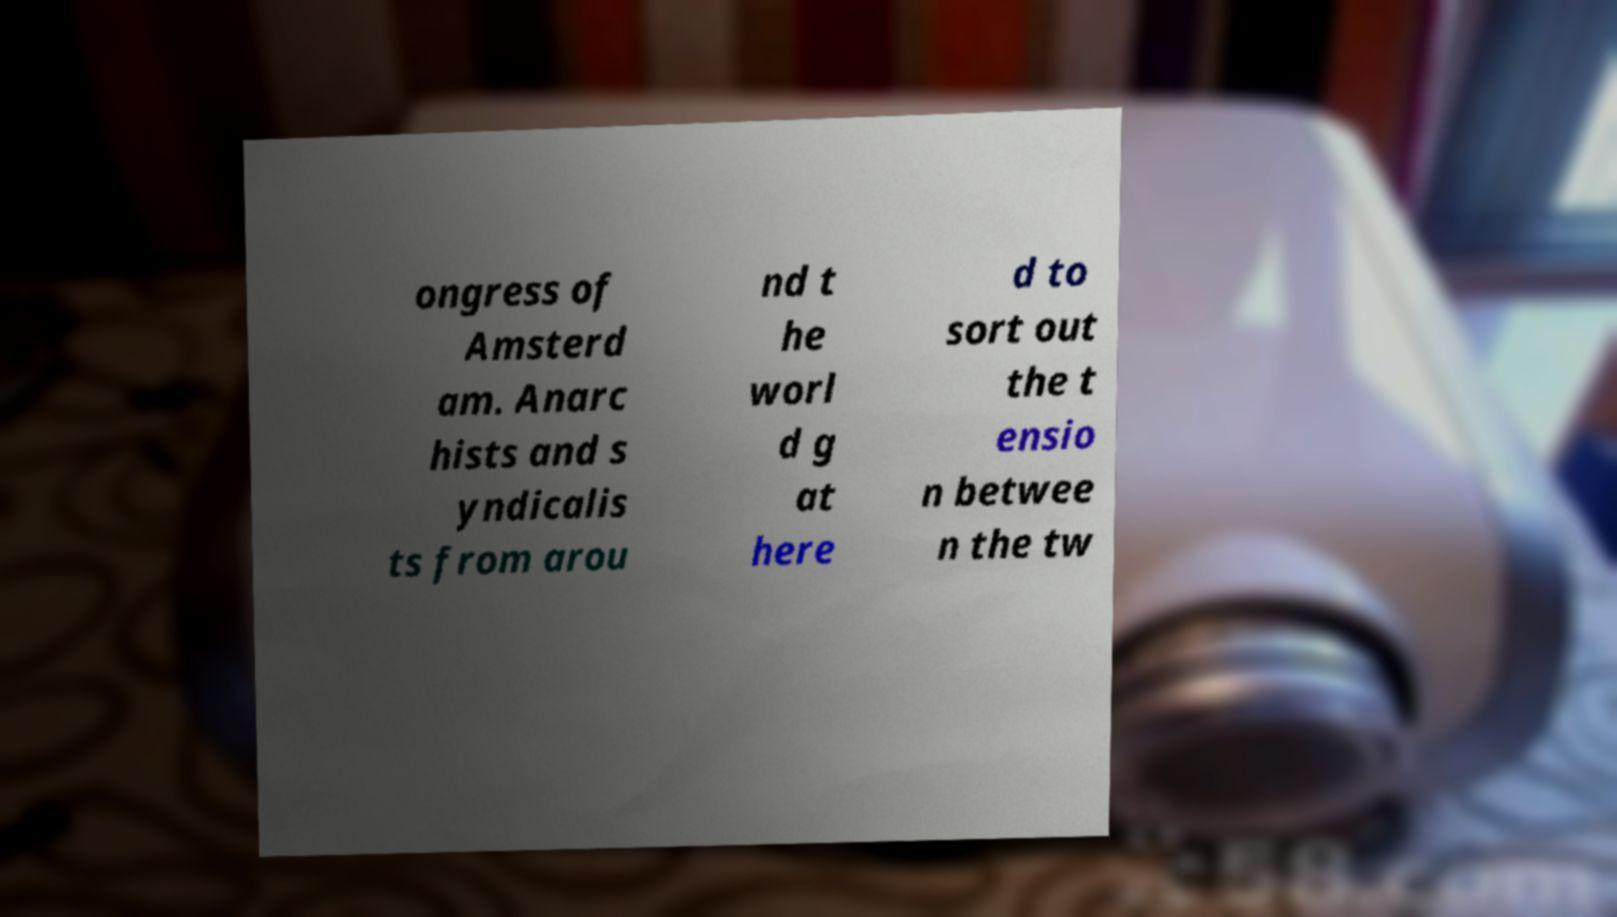Can you accurately transcribe the text from the provided image for me? ongress of Amsterd am. Anarc hists and s yndicalis ts from arou nd t he worl d g at here d to sort out the t ensio n betwee n the tw 